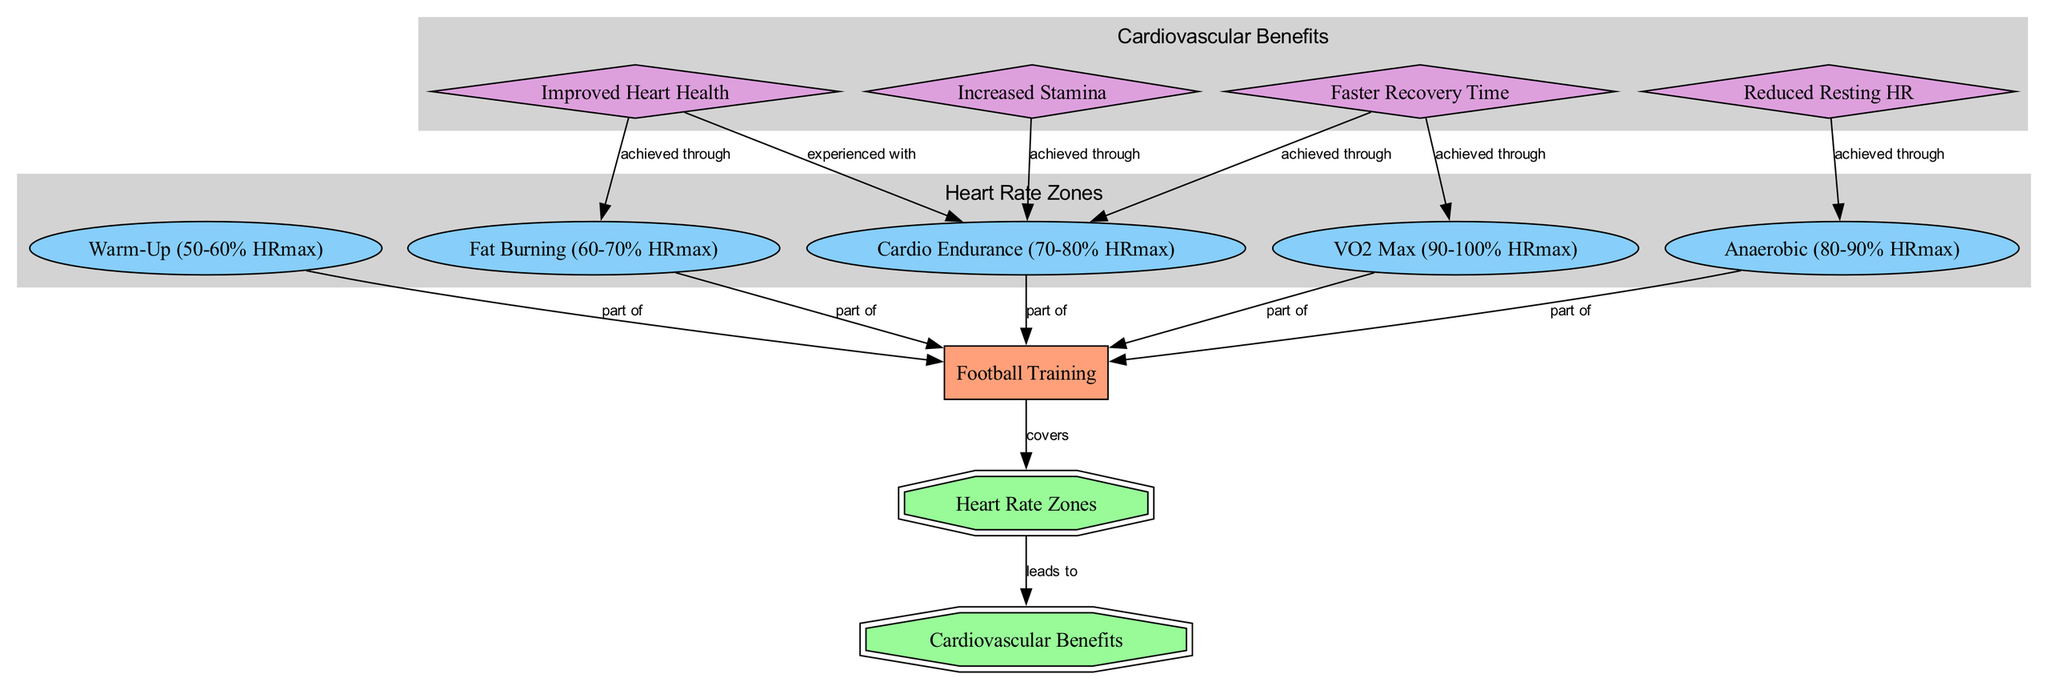What is the main process depicted in the diagram? The main process shown in the diagram is "Football Training," which is the starting point and central theme of the diagram. It is connected to various nodes representing heart rate zones and cardiovascular benefits.
Answer: Football Training How many heart rate zones are represented in the diagram? The diagram showcases a total of five heart rate zones, each represented as a state node under the "Heart Rate Zones" group.
Answer: 5 Which heart rate zone is categorized as the highest intensity? The highest intensity heart rate zone depicted in the diagram is labeled "VO2 Max (90-100% HRmax)," indicating it functions at this peak heart rate range.
Answer: VO2 Max What benefit is achieved through the "Anaerobic" zone? "Reduced Resting HR" is the benefit associated with the "Anaerobic" zone, which is indicated by an edge connecting these two nodes in the diagram.
Answer: Reduced Resting HR Which benefit is linked to both "Fat Burning" and "Cardio Endurance"? The benefit "Improved Heart Health" is linked to both the "Fat Burning" and "Cardio Endurance" zones as seen in the two separate edges from "Improved Heart Health" to these states.
Answer: Improved Heart Health How does "Better Recovery" connect to the heart rate zones? "Better Recovery" is achieved through both the "VO2 Max" and "Cardio Endurance" zones, as shown by edges pointing from these heart rate zones to the "Better Recovery" benefit node.
Answer: VO2 Max, Cardio Endurance In which heart rate zone is "Increased Stamina" specifically achieved? "Increased Stamina" is specifically achieved through the "Cardio Endurance" zone, as indicated by the edge connecting these two nodes in the diagram.
Answer: Cardio Endurance What is the relationship between "Football Training" and "Cardiovascular Benefits"? The relationship is that "Football Training" covers the "Heart Rate Zones," which then leads to the "Cardiovascular Benefits," reflecting a flow of influence from training to benefits.
Answer: leads to Which state directly represents the lower intensity in the heart rate zones? The lower intensity heart rate zone directly represented is "Warm-Up (50-60% HRmax)," as it describes the initial phase of training with the least intensity among the stated zones.
Answer: Warm-Up 